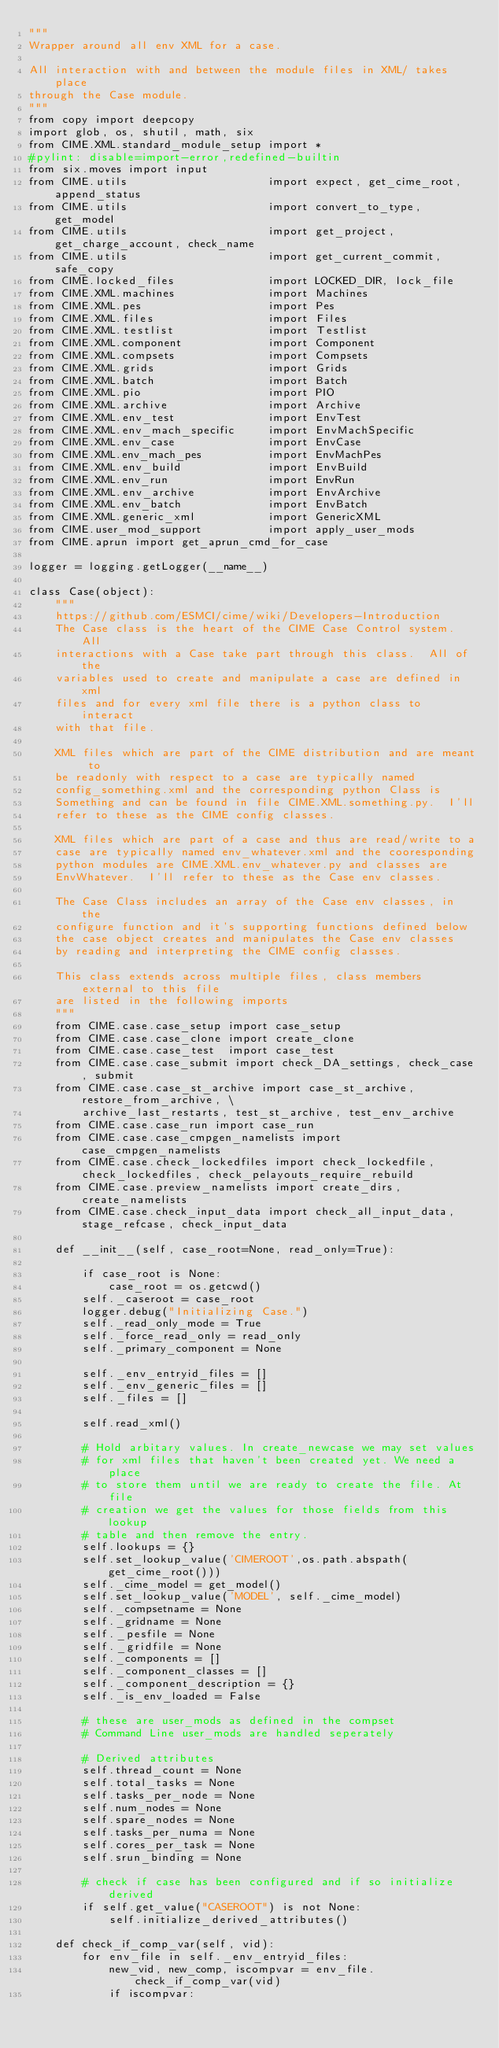Convert code to text. <code><loc_0><loc_0><loc_500><loc_500><_Python_>"""
Wrapper around all env XML for a case.

All interaction with and between the module files in XML/ takes place
through the Case module.
"""
from copy import deepcopy
import glob, os, shutil, math, six
from CIME.XML.standard_module_setup import *
#pylint: disable=import-error,redefined-builtin
from six.moves import input
from CIME.utils                     import expect, get_cime_root, append_status
from CIME.utils                     import convert_to_type, get_model
from CIME.utils                     import get_project, get_charge_account, check_name
from CIME.utils                     import get_current_commit, safe_copy
from CIME.locked_files              import LOCKED_DIR, lock_file
from CIME.XML.machines              import Machines
from CIME.XML.pes                   import Pes
from CIME.XML.files                 import Files
from CIME.XML.testlist              import Testlist
from CIME.XML.component             import Component
from CIME.XML.compsets              import Compsets
from CIME.XML.grids                 import Grids
from CIME.XML.batch                 import Batch
from CIME.XML.pio                   import PIO
from CIME.XML.archive               import Archive
from CIME.XML.env_test              import EnvTest
from CIME.XML.env_mach_specific     import EnvMachSpecific
from CIME.XML.env_case              import EnvCase
from CIME.XML.env_mach_pes          import EnvMachPes
from CIME.XML.env_build             import EnvBuild
from CIME.XML.env_run               import EnvRun
from CIME.XML.env_archive           import EnvArchive
from CIME.XML.env_batch             import EnvBatch
from CIME.XML.generic_xml           import GenericXML
from CIME.user_mod_support          import apply_user_mods
from CIME.aprun import get_aprun_cmd_for_case

logger = logging.getLogger(__name__)

class Case(object):
    """
    https://github.com/ESMCI/cime/wiki/Developers-Introduction
    The Case class is the heart of the CIME Case Control system.  All
    interactions with a Case take part through this class.  All of the
    variables used to create and manipulate a case are defined in xml
    files and for every xml file there is a python class to interact
    with that file.

    XML files which are part of the CIME distribution and are meant to
    be readonly with respect to a case are typically named
    config_something.xml and the corresponding python Class is
    Something and can be found in file CIME.XML.something.py.  I'll
    refer to these as the CIME config classes.

    XML files which are part of a case and thus are read/write to a
    case are typically named env_whatever.xml and the cooresponding
    python modules are CIME.XML.env_whatever.py and classes are
    EnvWhatever.  I'll refer to these as the Case env classes.

    The Case Class includes an array of the Case env classes, in the
    configure function and it's supporting functions defined below
    the case object creates and manipulates the Case env classes
    by reading and interpreting the CIME config classes.

    This class extends across multiple files, class members external to this file
    are listed in the following imports
    """
    from CIME.case.case_setup import case_setup
    from CIME.case.case_clone import create_clone
    from CIME.case.case_test  import case_test
    from CIME.case.case_submit import check_DA_settings, check_case, submit
    from CIME.case.case_st_archive import case_st_archive, restore_from_archive, \
        archive_last_restarts, test_st_archive, test_env_archive
    from CIME.case.case_run import case_run
    from CIME.case.case_cmpgen_namelists import case_cmpgen_namelists
    from CIME.case.check_lockedfiles import check_lockedfile, check_lockedfiles, check_pelayouts_require_rebuild
    from CIME.case.preview_namelists import create_dirs, create_namelists
    from CIME.case.check_input_data import check_all_input_data, stage_refcase, check_input_data

    def __init__(self, case_root=None, read_only=True):

        if case_root is None:
            case_root = os.getcwd()
        self._caseroot = case_root
        logger.debug("Initializing Case.")
        self._read_only_mode = True
        self._force_read_only = read_only
        self._primary_component = None

        self._env_entryid_files = []
        self._env_generic_files = []
        self._files = []

        self.read_xml()

        # Hold arbitary values. In create_newcase we may set values
        # for xml files that haven't been created yet. We need a place
        # to store them until we are ready to create the file. At file
        # creation we get the values for those fields from this lookup
        # table and then remove the entry.
        self.lookups = {}
        self.set_lookup_value('CIMEROOT',os.path.abspath(get_cime_root()))
        self._cime_model = get_model()
        self.set_lookup_value('MODEL', self._cime_model)
        self._compsetname = None
        self._gridname = None
        self._pesfile = None
        self._gridfile = None
        self._components = []
        self._component_classes = []
        self._component_description = {}
        self._is_env_loaded = False

        # these are user_mods as defined in the compset
        # Command Line user_mods are handled seperately

        # Derived attributes
        self.thread_count = None
        self.total_tasks = None
        self.tasks_per_node = None
        self.num_nodes = None
        self.spare_nodes = None
        self.tasks_per_numa = None
        self.cores_per_task = None
        self.srun_binding = None

        # check if case has been configured and if so initialize derived
        if self.get_value("CASEROOT") is not None:
            self.initialize_derived_attributes()

    def check_if_comp_var(self, vid):
        for env_file in self._env_entryid_files:
            new_vid, new_comp, iscompvar = env_file.check_if_comp_var(vid)
            if iscompvar:</code> 